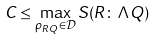<formula> <loc_0><loc_0><loc_500><loc_500>C \leq \max _ { \rho _ { R Q } \in \mathcal { D } } S ( R \colon \Lambda Q )</formula> 